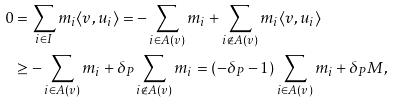Convert formula to latex. <formula><loc_0><loc_0><loc_500><loc_500>0 & = \sum _ { i \in I } m _ { i } \langle v , u _ { i } \rangle = - \sum _ { i \in A ( v ) } m _ { i } + \sum _ { i \not \in A ( v ) } m _ { i } \langle v , u _ { i } \rangle \\ & \geq - \sum _ { i \in A ( v ) } m _ { i } + \delta _ { P } \sum _ { i \not \in A ( v ) } m _ { i } = ( - \delta _ { P } - 1 ) \sum _ { i \in A ( v ) } m _ { i } + \delta _ { P } M ,</formula> 